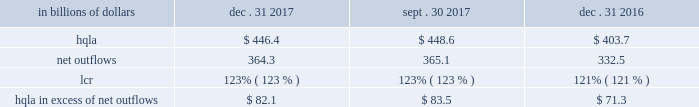Liquidity monitoring and measurement stress testing liquidity stress testing is performed for each of citi 2019s major entities , operating subsidiaries and/or countries .
Stress testing and scenario analyses are intended to quantify the potential impact of an adverse liquidity event on the balance sheet and liquidity position , and to identify viable funding alternatives that can be utilized .
These scenarios include assumptions about significant changes in key funding sources , market triggers ( such as credit ratings ) , potential uses of funding and geopolitical and macroeconomic conditions .
These conditions include expected and stressed market conditions as well as company-specific events .
Liquidity stress tests are conducted to ascertain potential mismatches between liquidity sources and uses over a variety of time horizons and over different stressed conditions .
Liquidity limits are set accordingly .
To monitor the liquidity of an entity , these stress tests and potential mismatches are calculated with varying frequencies , with several tests performed daily .
Given the range of potential stresses , citi maintains contingency funding plans on a consolidated basis and for individual entities .
These plans specify a wide range of readily available actions for a variety of adverse market conditions or idiosyncratic stresses .
Short-term liquidity measurement : liquidity coverage ratio ( lcr ) in addition to internal liquidity stress metrics that citi has developed for a 30-day stress scenario , citi also monitors its liquidity by reference to the lcr , as calculated pursuant to the u.s .
Lcr rules .
Generally , the lcr is designed to ensure that banks maintain an adequate level of hqla to meet liquidity needs under an acute 30-day stress scenario .
The lcr is calculated by dividing hqla by estimated net outflows over a stressed 30-day period , with the net outflows determined by applying prescribed outflow factors to various categories of liabilities , such as deposits , unsecured and secured wholesale borrowings , unused lending commitments and derivatives- related exposures , partially offset by inflows from assets maturing within 30 days .
Banks are required to calculate an add-on to address potential maturity mismatches between contractual cash outflows and inflows within the 30-day period in determining the total amount of net outflows .
The minimum lcr requirement is 100% ( 100 % ) , effective january 2017 .
Pursuant to the federal reserve board 2019s final rule regarding lcr disclosures , effective april 1 , 2017 , citi began to disclose lcr in the prescribed format .
The table below sets forth the components of citi 2019s lcr calculation and hqla in excess of net outflows for the periods indicated : in billions of dollars dec .
31 , sept .
30 , dec .
31 .
Note : amounts set forth in the table above are presented on an average basis .
As set forth in the table above , citi 2019s lcr increased year- over-year , as the increase in the hqla ( as discussed above ) more than offset an increase in modeled net outflows .
The increase in modeled net outflows was primarily driven by changes in assumptions , including changes in methodology to better align citi 2019s outflow assumptions with those embedded in its resolution planning .
Sequentially , citi 2019s lcr remained unchanged .
Long-term liquidity measurement : net stable funding ratio ( nsfr ) in 2016 , the federal reserve board , the fdic and the occ issued a proposed rule to implement the basel iii nsfr requirement .
The u.s.-proposed nsfr is largely consistent with the basel committee 2019s final nsfr rules .
In general , the nsfr assesses the availability of a bank 2019s stable funding against a required level .
A bank 2019s available stable funding would include portions of equity , deposits and long-term debt , while its required stable funding would be based on the liquidity characteristics of its assets , derivatives and commitments .
Prescribed factors would be required to be applied to the various categories of asset and liabilities classes .
The ratio of available stable funding to required stable funding would be required to be greater than 100% ( 100 % ) .
While citi believes that it is compliant with the proposed u.s .
Nsfr rules as of december 31 , 2017 , it will need to evaluate a final version of the rules , which are expected to be released during 2018 .
Citi expects that the nsfr final rules implementation period will be communicated along with the final version of the rules. .
What was the change in billions of net outflows from dec . 31 , 2016 to dec . 31 , 2017? 
Computations: (364.3 - 332.5)
Answer: 31.8. 